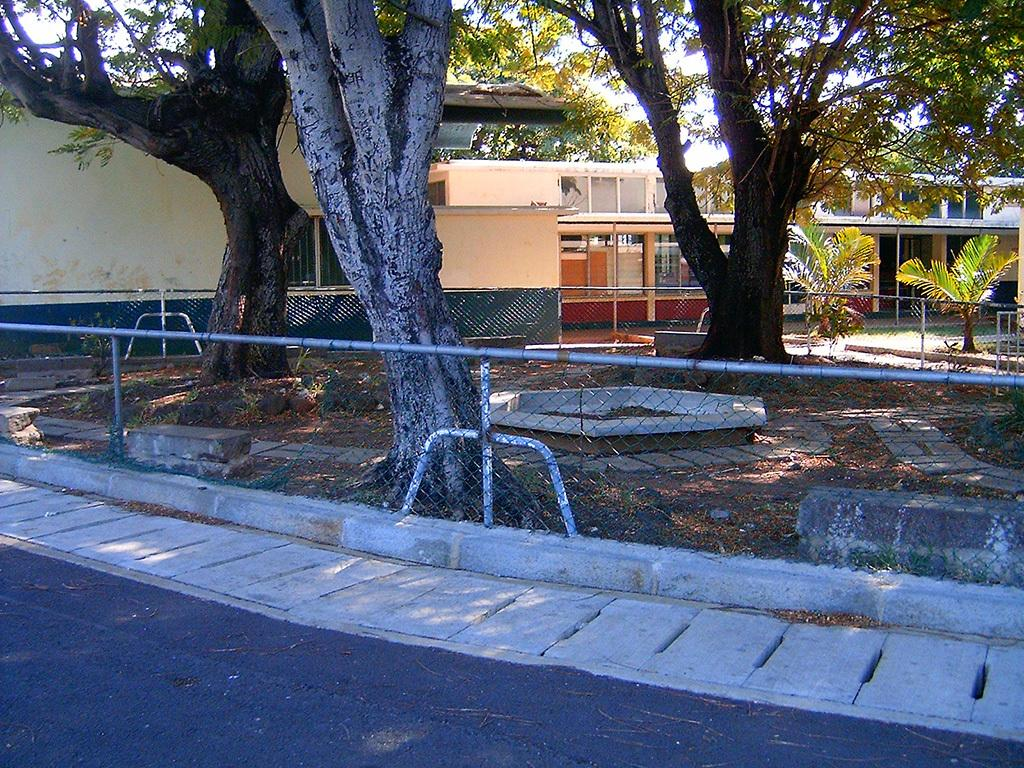What type of structure can be seen in the image? There is a fence in the image. What natural elements are present in the image? There are trees in the image. What man-made structures can be seen in the image? There are buildings in the image. What other objects are visible in the image? There are other objects in the image. What can be seen in the background of the image? The sky is visible in the background of the image. How many girls are kicking a balloon in the image? There are no girls or balloons present in the image. What type of kick is being performed by the girls in the image? There are no girls or kicks present in the image. 